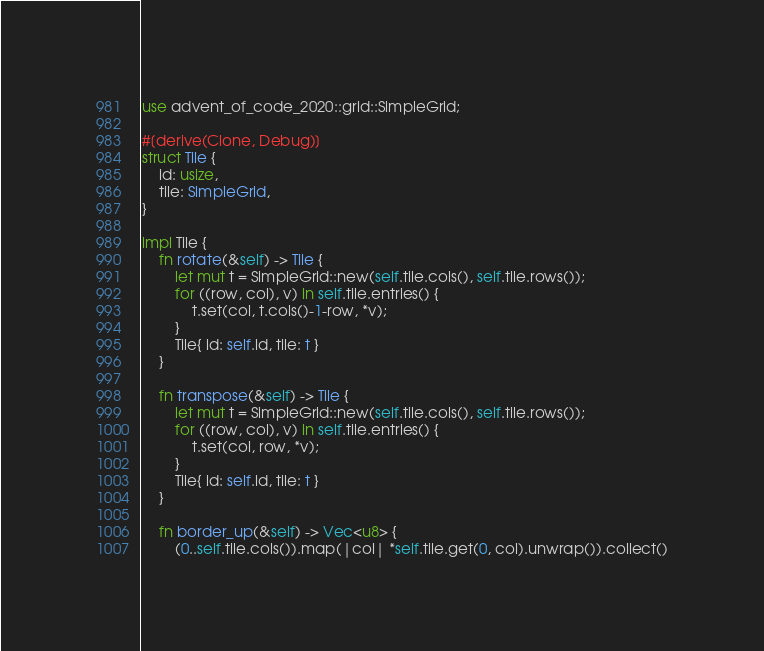Convert code to text. <code><loc_0><loc_0><loc_500><loc_500><_Rust_>use advent_of_code_2020::grid::SimpleGrid;

#[derive(Clone, Debug)]
struct Tile {
    id: usize,
    tile: SimpleGrid,
}

impl Tile {
    fn rotate(&self) -> Tile {
        let mut t = SimpleGrid::new(self.tile.cols(), self.tile.rows());
        for ((row, col), v) in self.tile.entries() {
            t.set(col, t.cols()-1-row, *v);
        }
        Tile{ id: self.id, tile: t }
    }

    fn transpose(&self) -> Tile {
        let mut t = SimpleGrid::new(self.tile.cols(), self.tile.rows());
        for ((row, col), v) in self.tile.entries() {
            t.set(col, row, *v);
        }
        Tile{ id: self.id, tile: t }
    }

    fn border_up(&self) -> Vec<u8> {
        (0..self.tile.cols()).map(|col| *self.tile.get(0, col).unwrap()).collect()</code> 